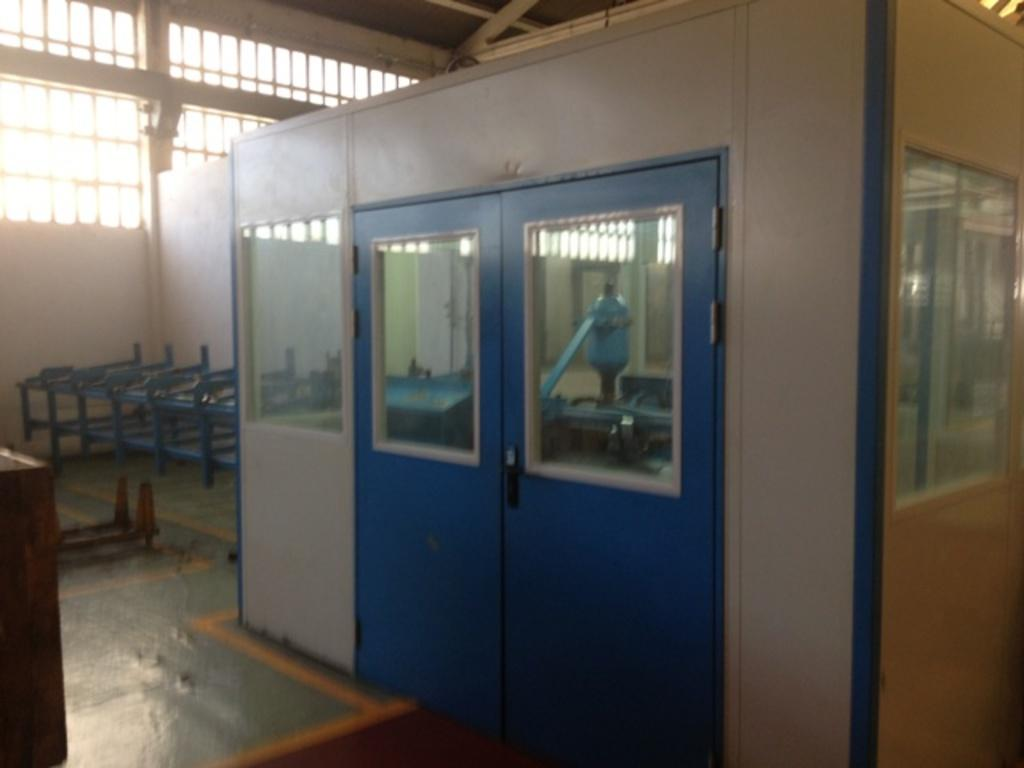What color is the door that is visible in the image? The door in the image is blue. Where is the blue door located in the image? The blue door is in the right corner of the image. What else can be seen in the image besides the blue door? There are other objects beside the blue door. How many chickens are visible in the image? There are no chickens present in the image. What type of weather condition is depicted in the image? The provided facts do not mention any weather conditions, so it cannot be determined from the image. 